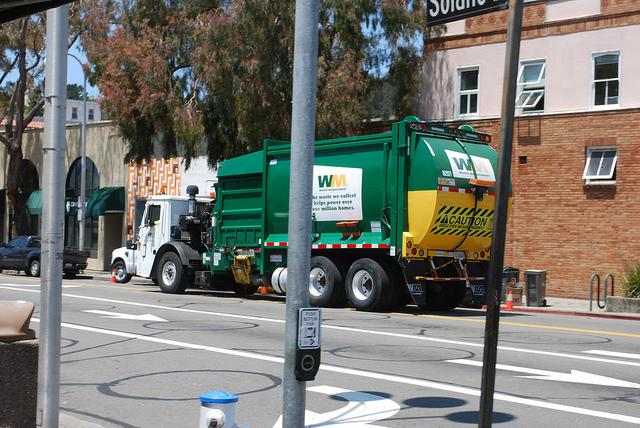What kind of product is likely hauled by the green truck?

Choices:
A) furniture
B) electronics
C) waste
D) wood waste 